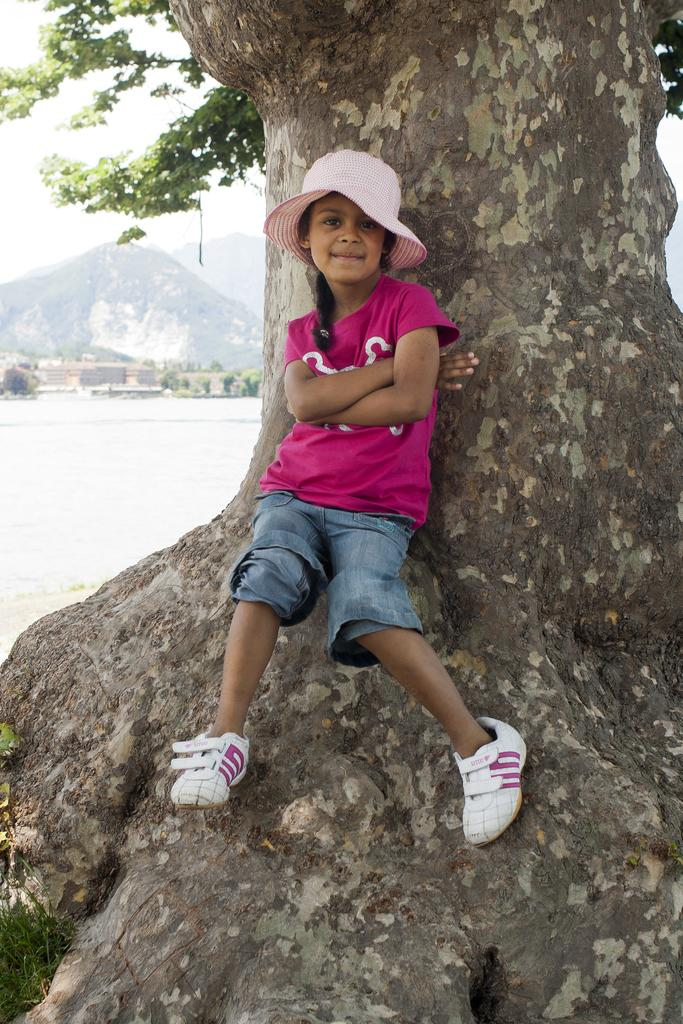Who is the main subject in the image? There is a girl in the image. What is the girl doing in the image? The girl is standing on a tree. What type of clothing is the girl wearing? The girl is wearing a t-shirt, a hat, and shoes. What can be seen on the left side of the image? There is water on the left side of the image. What type of prose is the girl reciting in the image? There is no indication in the image that the girl is reciting any prose. What theory does the girl's hat represent in the image? The girl's hat does not represent any theory in the image. 